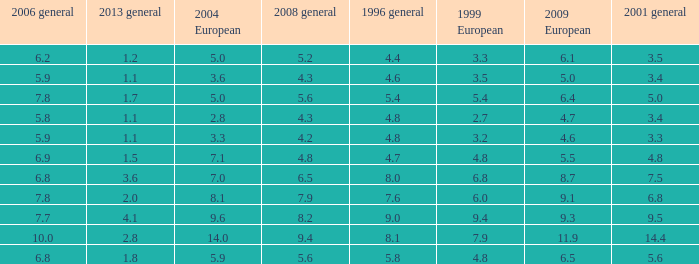What is the lowest value for 2004 European when 1999 European is 3.3 and less than 4.4 in 1996 general? None. 